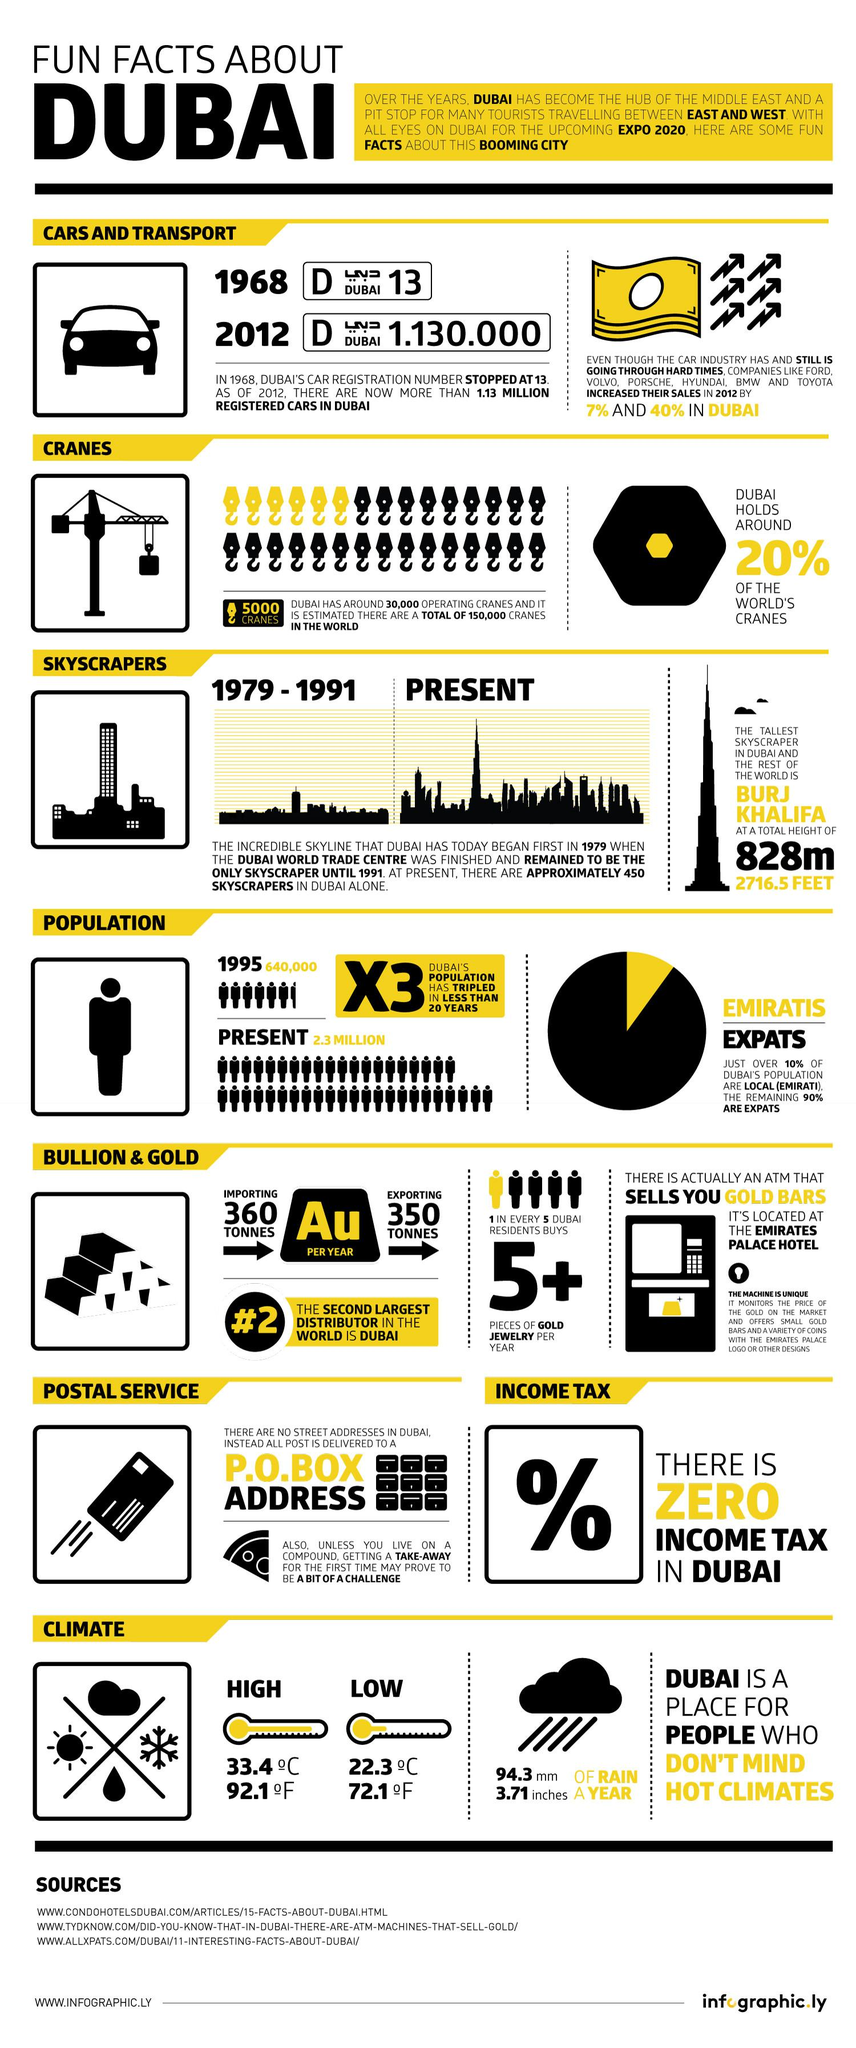Point out several critical features in this image. In a year, Dubai receives approximately 94.3 millimeters of rain on average. The lowest temperature in Dubai, measured in degrees Celsius, is 22.3. Burj Khalifa, located in Dubai, United Arab Emirates, has a height of 828 meters. Dubai has reached a temperature of 33.4 degrees Celsius, which is its highest recorded temperature. It is estimated that only 20% of the world's cranes are not owned by Dubai. 